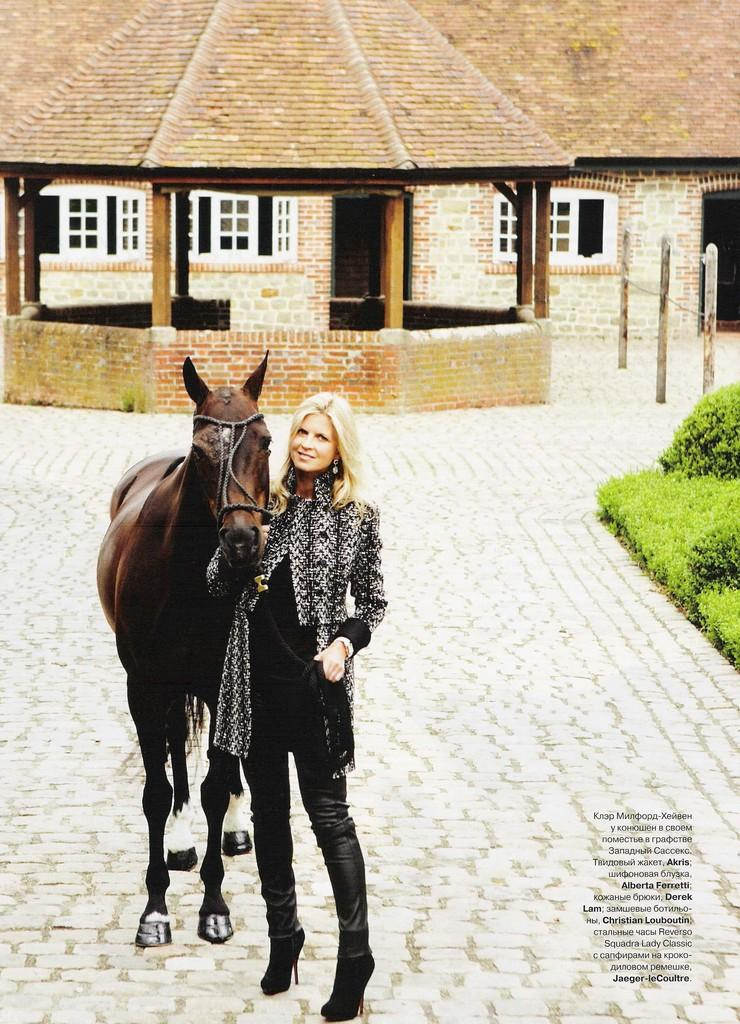Who is present in the image? There is a woman in the image. What is the woman doing in the image? The woman is standing beside a horse. What can be seen in the background of the image? There is a building and shrubs in the background of the image. What type of sugar is being used to grow the club in the image? There is no sugar, growth, or club present in the image. 